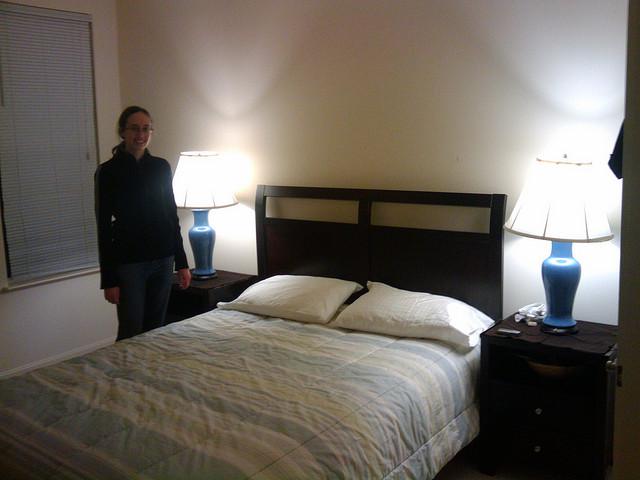Is this a hotel room?
Quick response, please. Yes. Is this a mugshot?
Quick response, please. No. Are the lights on?
Be succinct. Yes. What are the duplicate items in the photo?
Give a very brief answer. Lamps. 